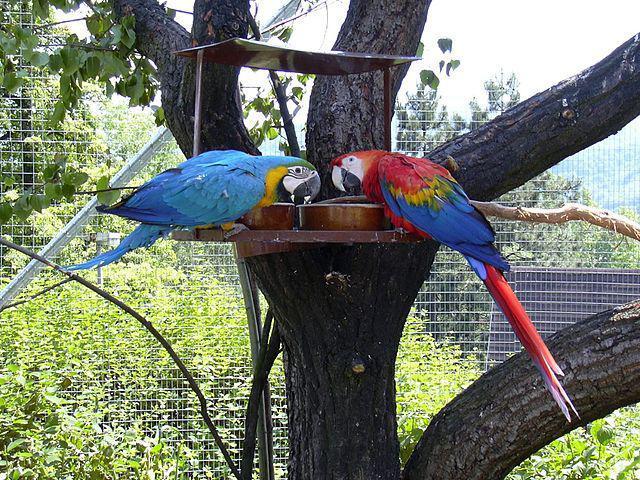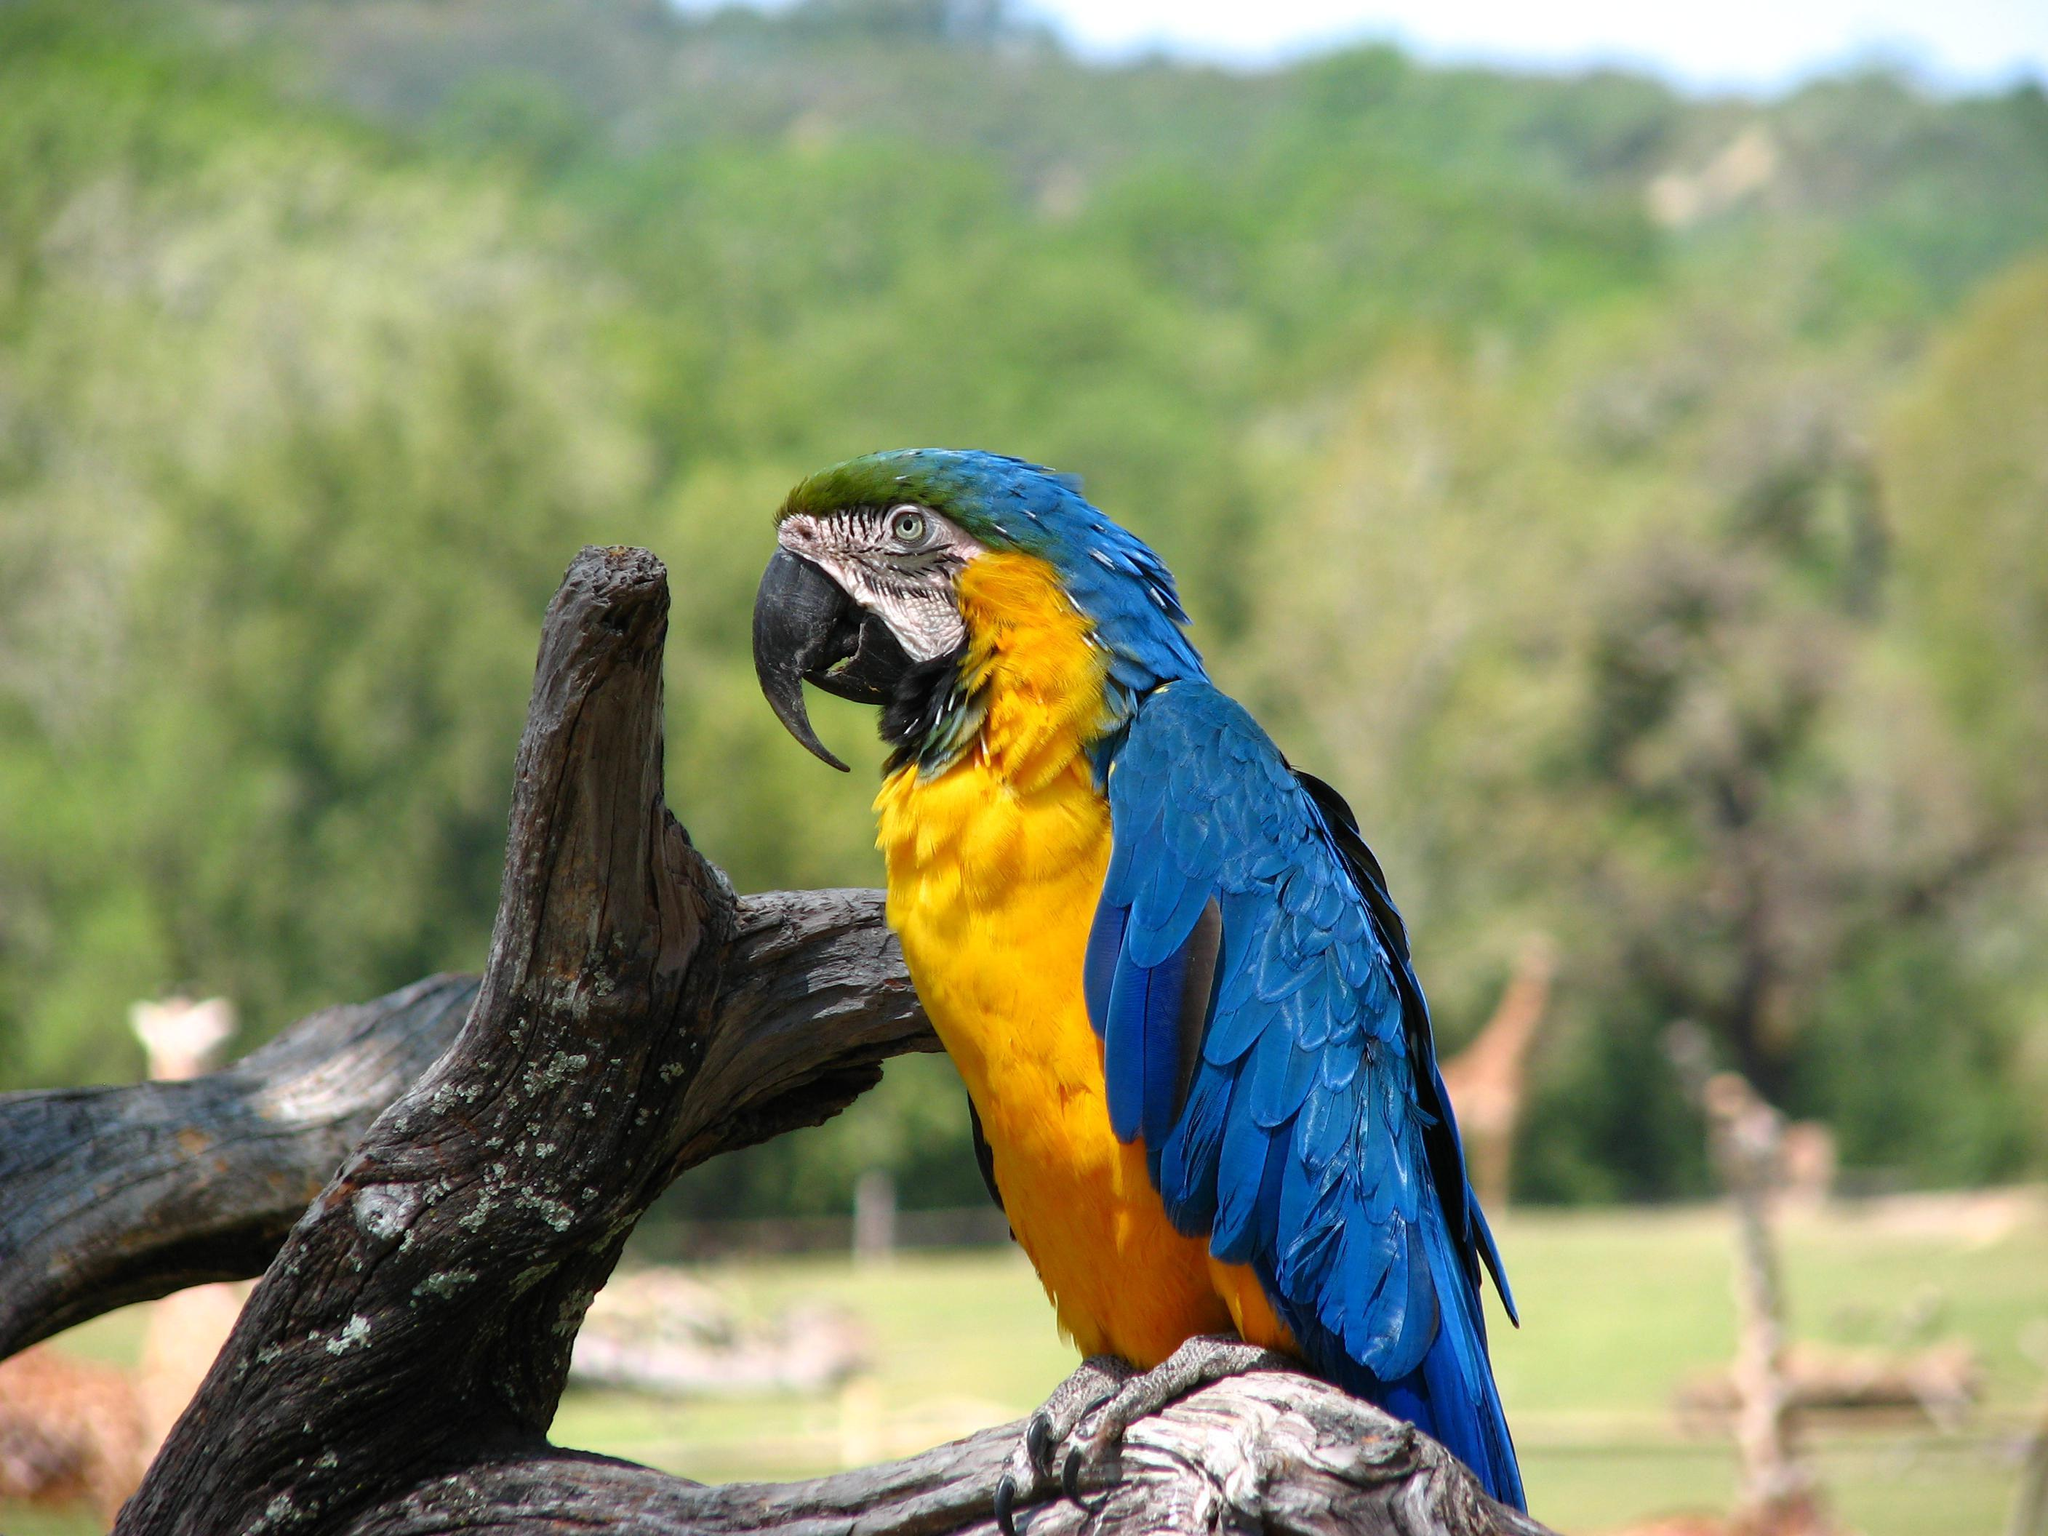The first image is the image on the left, the second image is the image on the right. Evaluate the accuracy of this statement regarding the images: "The left image contains exactly two parrots.". Is it true? Answer yes or no. Yes. The first image is the image on the left, the second image is the image on the right. For the images shown, is this caption "A single blue and yellow bird is perched in one of the images." true? Answer yes or no. Yes. 